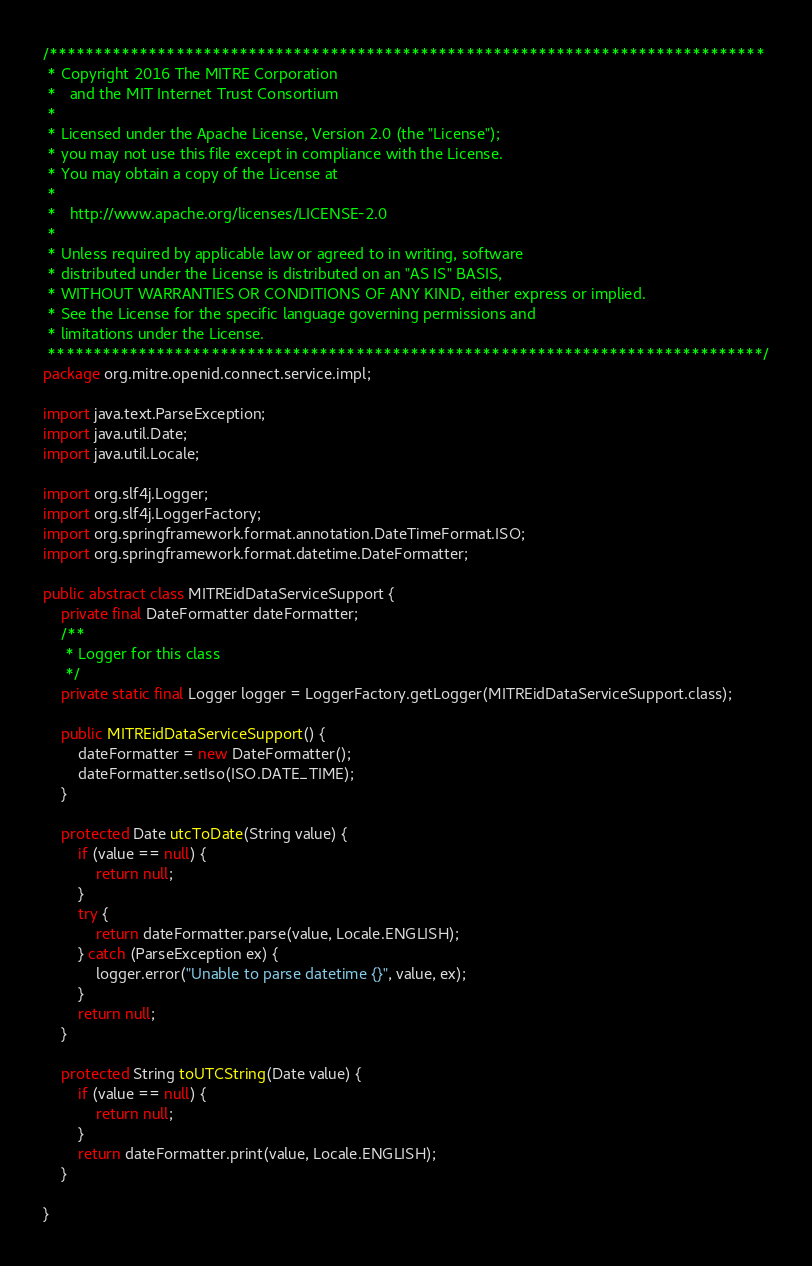<code> <loc_0><loc_0><loc_500><loc_500><_Java_>/*******************************************************************************
 * Copyright 2016 The MITRE Corporation
 *   and the MIT Internet Trust Consortium
 *
 * Licensed under the Apache License, Version 2.0 (the "License");
 * you may not use this file except in compliance with the License.
 * You may obtain a copy of the License at
 *
 *   http://www.apache.org/licenses/LICENSE-2.0
 *
 * Unless required by applicable law or agreed to in writing, software
 * distributed under the License is distributed on an "AS IS" BASIS,
 * WITHOUT WARRANTIES OR CONDITIONS OF ANY KIND, either express or implied.
 * See the License for the specific language governing permissions and
 * limitations under the License.
 *******************************************************************************/
package org.mitre.openid.connect.service.impl;

import java.text.ParseException;
import java.util.Date;
import java.util.Locale;

import org.slf4j.Logger;
import org.slf4j.LoggerFactory;
import org.springframework.format.annotation.DateTimeFormat.ISO;
import org.springframework.format.datetime.DateFormatter;

public abstract class MITREidDataServiceSupport {
	private final DateFormatter dateFormatter;
	/**
	 * Logger for this class
	 */
	private static final Logger logger = LoggerFactory.getLogger(MITREidDataServiceSupport.class);

	public MITREidDataServiceSupport() {
		dateFormatter = new DateFormatter();
		dateFormatter.setIso(ISO.DATE_TIME);
	}

	protected Date utcToDate(String value) {
		if (value == null) {
			return null;
		}
		try {
			return dateFormatter.parse(value, Locale.ENGLISH);
		} catch (ParseException ex) {
			logger.error("Unable to parse datetime {}", value, ex);
		}
		return null;
	}

	protected String toUTCString(Date value) {
		if (value == null) {
			return null;
		}
		return dateFormatter.print(value, Locale.ENGLISH);
	}

}
</code> 